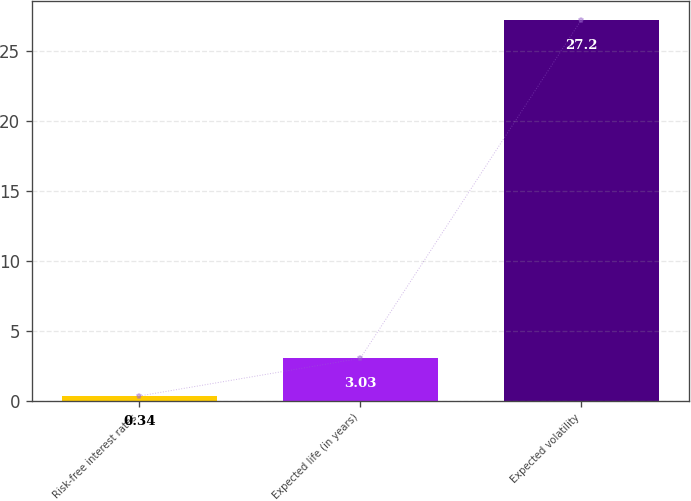<chart> <loc_0><loc_0><loc_500><loc_500><bar_chart><fcel>Risk-free interest rates<fcel>Expected life (in years)<fcel>Expected volatility<nl><fcel>0.34<fcel>3.03<fcel>27.2<nl></chart> 